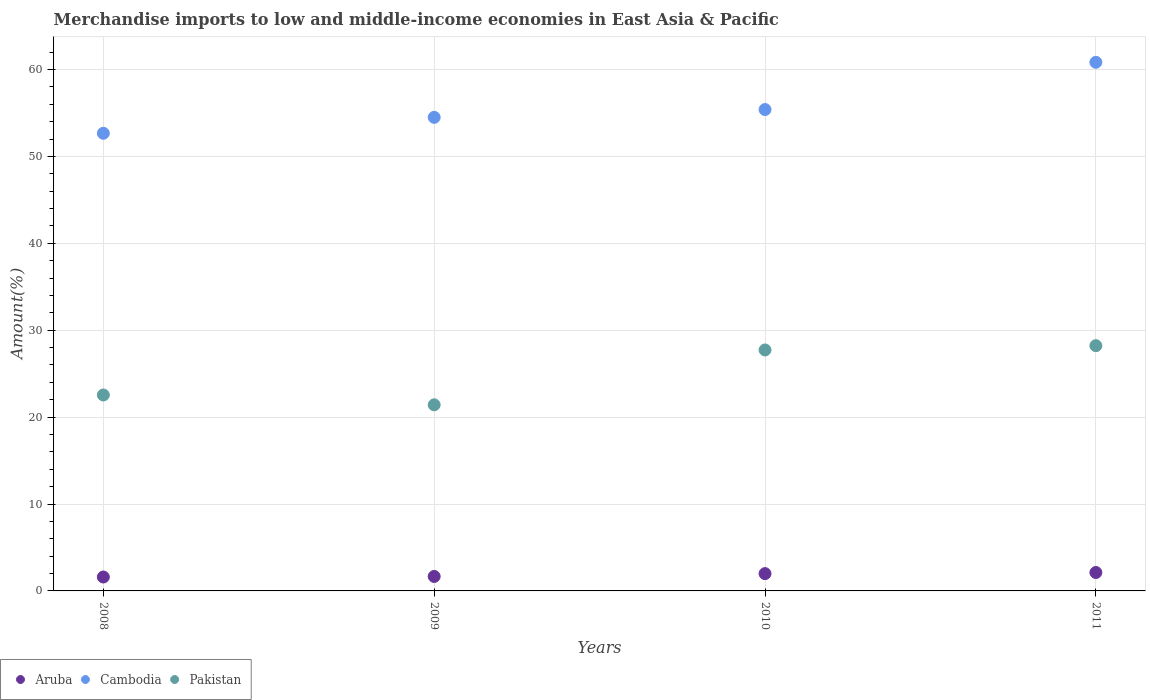How many different coloured dotlines are there?
Give a very brief answer. 3. Is the number of dotlines equal to the number of legend labels?
Your answer should be very brief. Yes. What is the percentage of amount earned from merchandise imports in Pakistan in 2011?
Provide a short and direct response. 28.22. Across all years, what is the maximum percentage of amount earned from merchandise imports in Cambodia?
Your answer should be compact. 60.83. Across all years, what is the minimum percentage of amount earned from merchandise imports in Aruba?
Give a very brief answer. 1.6. What is the total percentage of amount earned from merchandise imports in Aruba in the graph?
Give a very brief answer. 7.38. What is the difference between the percentage of amount earned from merchandise imports in Pakistan in 2009 and that in 2011?
Offer a terse response. -6.81. What is the difference between the percentage of amount earned from merchandise imports in Aruba in 2011 and the percentage of amount earned from merchandise imports in Pakistan in 2008?
Your answer should be very brief. -20.43. What is the average percentage of amount earned from merchandise imports in Pakistan per year?
Keep it short and to the point. 24.98. In the year 2009, what is the difference between the percentage of amount earned from merchandise imports in Pakistan and percentage of amount earned from merchandise imports in Aruba?
Your response must be concise. 19.75. What is the ratio of the percentage of amount earned from merchandise imports in Aruba in 2008 to that in 2011?
Give a very brief answer. 0.76. Is the difference between the percentage of amount earned from merchandise imports in Pakistan in 2009 and 2010 greater than the difference between the percentage of amount earned from merchandise imports in Aruba in 2009 and 2010?
Provide a short and direct response. No. What is the difference between the highest and the second highest percentage of amount earned from merchandise imports in Cambodia?
Ensure brevity in your answer.  5.44. What is the difference between the highest and the lowest percentage of amount earned from merchandise imports in Cambodia?
Ensure brevity in your answer.  8.17. In how many years, is the percentage of amount earned from merchandise imports in Pakistan greater than the average percentage of amount earned from merchandise imports in Pakistan taken over all years?
Keep it short and to the point. 2. Is the sum of the percentage of amount earned from merchandise imports in Cambodia in 2009 and 2011 greater than the maximum percentage of amount earned from merchandise imports in Pakistan across all years?
Give a very brief answer. Yes. Is it the case that in every year, the sum of the percentage of amount earned from merchandise imports in Aruba and percentage of amount earned from merchandise imports in Cambodia  is greater than the percentage of amount earned from merchandise imports in Pakistan?
Make the answer very short. Yes. Does the percentage of amount earned from merchandise imports in Cambodia monotonically increase over the years?
Your response must be concise. Yes. Is the percentage of amount earned from merchandise imports in Aruba strictly greater than the percentage of amount earned from merchandise imports in Cambodia over the years?
Keep it short and to the point. No. How many years are there in the graph?
Keep it short and to the point. 4. What is the difference between two consecutive major ticks on the Y-axis?
Make the answer very short. 10. Are the values on the major ticks of Y-axis written in scientific E-notation?
Offer a terse response. No. Does the graph contain any zero values?
Ensure brevity in your answer.  No. Does the graph contain grids?
Ensure brevity in your answer.  Yes. How many legend labels are there?
Your answer should be compact. 3. How are the legend labels stacked?
Your answer should be very brief. Horizontal. What is the title of the graph?
Give a very brief answer. Merchandise imports to low and middle-income economies in East Asia & Pacific. What is the label or title of the X-axis?
Make the answer very short. Years. What is the label or title of the Y-axis?
Ensure brevity in your answer.  Amount(%). What is the Amount(%) of Aruba in 2008?
Offer a very short reply. 1.6. What is the Amount(%) of Cambodia in 2008?
Your answer should be compact. 52.67. What is the Amount(%) of Pakistan in 2008?
Ensure brevity in your answer.  22.55. What is the Amount(%) in Aruba in 2009?
Your answer should be very brief. 1.67. What is the Amount(%) of Cambodia in 2009?
Offer a terse response. 54.5. What is the Amount(%) in Pakistan in 2009?
Ensure brevity in your answer.  21.42. What is the Amount(%) in Aruba in 2010?
Keep it short and to the point. 1.99. What is the Amount(%) in Cambodia in 2010?
Ensure brevity in your answer.  55.4. What is the Amount(%) in Pakistan in 2010?
Your answer should be very brief. 27.73. What is the Amount(%) in Aruba in 2011?
Give a very brief answer. 2.12. What is the Amount(%) in Cambodia in 2011?
Provide a short and direct response. 60.83. What is the Amount(%) of Pakistan in 2011?
Provide a short and direct response. 28.22. Across all years, what is the maximum Amount(%) of Aruba?
Keep it short and to the point. 2.12. Across all years, what is the maximum Amount(%) in Cambodia?
Provide a short and direct response. 60.83. Across all years, what is the maximum Amount(%) in Pakistan?
Offer a terse response. 28.22. Across all years, what is the minimum Amount(%) of Aruba?
Make the answer very short. 1.6. Across all years, what is the minimum Amount(%) in Cambodia?
Ensure brevity in your answer.  52.67. Across all years, what is the minimum Amount(%) of Pakistan?
Make the answer very short. 21.42. What is the total Amount(%) of Aruba in the graph?
Provide a short and direct response. 7.38. What is the total Amount(%) in Cambodia in the graph?
Keep it short and to the point. 223.4. What is the total Amount(%) in Pakistan in the graph?
Your response must be concise. 99.92. What is the difference between the Amount(%) in Aruba in 2008 and that in 2009?
Your response must be concise. -0.07. What is the difference between the Amount(%) in Cambodia in 2008 and that in 2009?
Offer a terse response. -1.83. What is the difference between the Amount(%) in Pakistan in 2008 and that in 2009?
Your response must be concise. 1.13. What is the difference between the Amount(%) in Aruba in 2008 and that in 2010?
Provide a succinct answer. -0.39. What is the difference between the Amount(%) of Cambodia in 2008 and that in 2010?
Offer a terse response. -2.73. What is the difference between the Amount(%) of Pakistan in 2008 and that in 2010?
Your answer should be very brief. -5.18. What is the difference between the Amount(%) of Aruba in 2008 and that in 2011?
Keep it short and to the point. -0.52. What is the difference between the Amount(%) of Cambodia in 2008 and that in 2011?
Provide a short and direct response. -8.17. What is the difference between the Amount(%) of Pakistan in 2008 and that in 2011?
Your response must be concise. -5.68. What is the difference between the Amount(%) of Aruba in 2009 and that in 2010?
Offer a very short reply. -0.33. What is the difference between the Amount(%) in Cambodia in 2009 and that in 2010?
Make the answer very short. -0.9. What is the difference between the Amount(%) in Pakistan in 2009 and that in 2010?
Your response must be concise. -6.31. What is the difference between the Amount(%) in Aruba in 2009 and that in 2011?
Keep it short and to the point. -0.45. What is the difference between the Amount(%) in Cambodia in 2009 and that in 2011?
Make the answer very short. -6.33. What is the difference between the Amount(%) of Pakistan in 2009 and that in 2011?
Your answer should be compact. -6.81. What is the difference between the Amount(%) of Aruba in 2010 and that in 2011?
Provide a succinct answer. -0.13. What is the difference between the Amount(%) of Cambodia in 2010 and that in 2011?
Your response must be concise. -5.44. What is the difference between the Amount(%) of Pakistan in 2010 and that in 2011?
Provide a short and direct response. -0.49. What is the difference between the Amount(%) of Aruba in 2008 and the Amount(%) of Cambodia in 2009?
Give a very brief answer. -52.9. What is the difference between the Amount(%) in Aruba in 2008 and the Amount(%) in Pakistan in 2009?
Provide a short and direct response. -19.82. What is the difference between the Amount(%) of Cambodia in 2008 and the Amount(%) of Pakistan in 2009?
Provide a succinct answer. 31.25. What is the difference between the Amount(%) of Aruba in 2008 and the Amount(%) of Cambodia in 2010?
Your answer should be compact. -53.8. What is the difference between the Amount(%) of Aruba in 2008 and the Amount(%) of Pakistan in 2010?
Offer a terse response. -26.13. What is the difference between the Amount(%) in Cambodia in 2008 and the Amount(%) in Pakistan in 2010?
Offer a very short reply. 24.94. What is the difference between the Amount(%) of Aruba in 2008 and the Amount(%) of Cambodia in 2011?
Provide a succinct answer. -59.23. What is the difference between the Amount(%) of Aruba in 2008 and the Amount(%) of Pakistan in 2011?
Keep it short and to the point. -26.62. What is the difference between the Amount(%) in Cambodia in 2008 and the Amount(%) in Pakistan in 2011?
Provide a short and direct response. 24.44. What is the difference between the Amount(%) in Aruba in 2009 and the Amount(%) in Cambodia in 2010?
Make the answer very short. -53.73. What is the difference between the Amount(%) of Aruba in 2009 and the Amount(%) of Pakistan in 2010?
Provide a succinct answer. -26.06. What is the difference between the Amount(%) of Cambodia in 2009 and the Amount(%) of Pakistan in 2010?
Ensure brevity in your answer.  26.77. What is the difference between the Amount(%) of Aruba in 2009 and the Amount(%) of Cambodia in 2011?
Your answer should be compact. -59.17. What is the difference between the Amount(%) in Aruba in 2009 and the Amount(%) in Pakistan in 2011?
Provide a succinct answer. -26.56. What is the difference between the Amount(%) in Cambodia in 2009 and the Amount(%) in Pakistan in 2011?
Offer a terse response. 26.27. What is the difference between the Amount(%) of Aruba in 2010 and the Amount(%) of Cambodia in 2011?
Ensure brevity in your answer.  -58.84. What is the difference between the Amount(%) in Aruba in 2010 and the Amount(%) in Pakistan in 2011?
Provide a short and direct response. -26.23. What is the difference between the Amount(%) of Cambodia in 2010 and the Amount(%) of Pakistan in 2011?
Make the answer very short. 27.17. What is the average Amount(%) of Aruba per year?
Keep it short and to the point. 1.84. What is the average Amount(%) of Cambodia per year?
Offer a very short reply. 55.85. What is the average Amount(%) of Pakistan per year?
Provide a succinct answer. 24.98. In the year 2008, what is the difference between the Amount(%) in Aruba and Amount(%) in Cambodia?
Your answer should be compact. -51.06. In the year 2008, what is the difference between the Amount(%) of Aruba and Amount(%) of Pakistan?
Provide a succinct answer. -20.95. In the year 2008, what is the difference between the Amount(%) of Cambodia and Amount(%) of Pakistan?
Keep it short and to the point. 30.12. In the year 2009, what is the difference between the Amount(%) of Aruba and Amount(%) of Cambodia?
Provide a succinct answer. -52.83. In the year 2009, what is the difference between the Amount(%) in Aruba and Amount(%) in Pakistan?
Make the answer very short. -19.75. In the year 2009, what is the difference between the Amount(%) in Cambodia and Amount(%) in Pakistan?
Ensure brevity in your answer.  33.08. In the year 2010, what is the difference between the Amount(%) in Aruba and Amount(%) in Cambodia?
Your answer should be very brief. -53.41. In the year 2010, what is the difference between the Amount(%) in Aruba and Amount(%) in Pakistan?
Give a very brief answer. -25.74. In the year 2010, what is the difference between the Amount(%) of Cambodia and Amount(%) of Pakistan?
Give a very brief answer. 27.67. In the year 2011, what is the difference between the Amount(%) in Aruba and Amount(%) in Cambodia?
Your answer should be compact. -58.71. In the year 2011, what is the difference between the Amount(%) in Aruba and Amount(%) in Pakistan?
Give a very brief answer. -26.1. In the year 2011, what is the difference between the Amount(%) of Cambodia and Amount(%) of Pakistan?
Your answer should be very brief. 32.61. What is the ratio of the Amount(%) in Cambodia in 2008 to that in 2009?
Keep it short and to the point. 0.97. What is the ratio of the Amount(%) of Pakistan in 2008 to that in 2009?
Your response must be concise. 1.05. What is the ratio of the Amount(%) of Aruba in 2008 to that in 2010?
Keep it short and to the point. 0.8. What is the ratio of the Amount(%) in Cambodia in 2008 to that in 2010?
Provide a succinct answer. 0.95. What is the ratio of the Amount(%) of Pakistan in 2008 to that in 2010?
Offer a very short reply. 0.81. What is the ratio of the Amount(%) of Aruba in 2008 to that in 2011?
Provide a succinct answer. 0.76. What is the ratio of the Amount(%) in Cambodia in 2008 to that in 2011?
Your answer should be compact. 0.87. What is the ratio of the Amount(%) of Pakistan in 2008 to that in 2011?
Keep it short and to the point. 0.8. What is the ratio of the Amount(%) of Aruba in 2009 to that in 2010?
Your answer should be compact. 0.84. What is the ratio of the Amount(%) of Cambodia in 2009 to that in 2010?
Ensure brevity in your answer.  0.98. What is the ratio of the Amount(%) in Pakistan in 2009 to that in 2010?
Your answer should be very brief. 0.77. What is the ratio of the Amount(%) in Aruba in 2009 to that in 2011?
Offer a terse response. 0.79. What is the ratio of the Amount(%) of Cambodia in 2009 to that in 2011?
Give a very brief answer. 0.9. What is the ratio of the Amount(%) of Pakistan in 2009 to that in 2011?
Your answer should be compact. 0.76. What is the ratio of the Amount(%) of Aruba in 2010 to that in 2011?
Your response must be concise. 0.94. What is the ratio of the Amount(%) in Cambodia in 2010 to that in 2011?
Provide a succinct answer. 0.91. What is the ratio of the Amount(%) in Pakistan in 2010 to that in 2011?
Your response must be concise. 0.98. What is the difference between the highest and the second highest Amount(%) of Aruba?
Offer a very short reply. 0.13. What is the difference between the highest and the second highest Amount(%) of Cambodia?
Your answer should be very brief. 5.44. What is the difference between the highest and the second highest Amount(%) of Pakistan?
Ensure brevity in your answer.  0.49. What is the difference between the highest and the lowest Amount(%) in Aruba?
Make the answer very short. 0.52. What is the difference between the highest and the lowest Amount(%) of Cambodia?
Keep it short and to the point. 8.17. What is the difference between the highest and the lowest Amount(%) of Pakistan?
Ensure brevity in your answer.  6.81. 